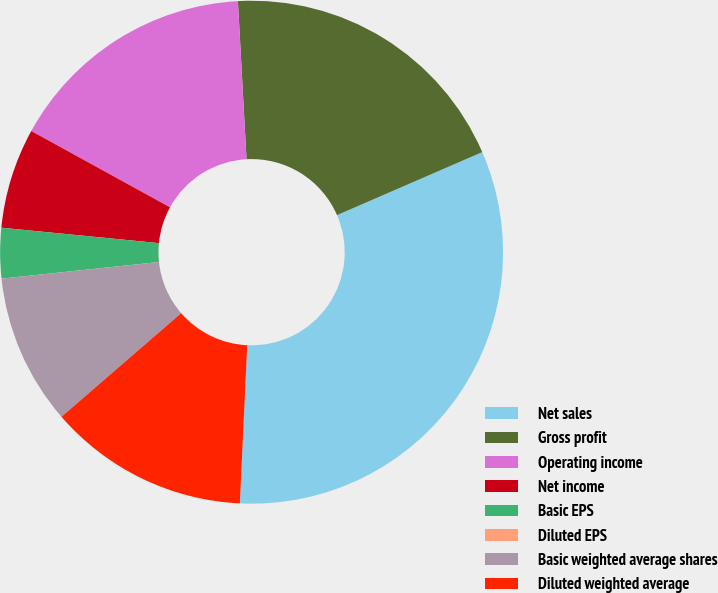Convert chart to OTSL. <chart><loc_0><loc_0><loc_500><loc_500><pie_chart><fcel>Net sales<fcel>Gross profit<fcel>Operating income<fcel>Net income<fcel>Basic EPS<fcel>Diluted EPS<fcel>Basic weighted average shares<fcel>Diluted weighted average<nl><fcel>32.26%<fcel>19.35%<fcel>16.13%<fcel>6.45%<fcel>3.23%<fcel>0.0%<fcel>9.68%<fcel>12.9%<nl></chart> 